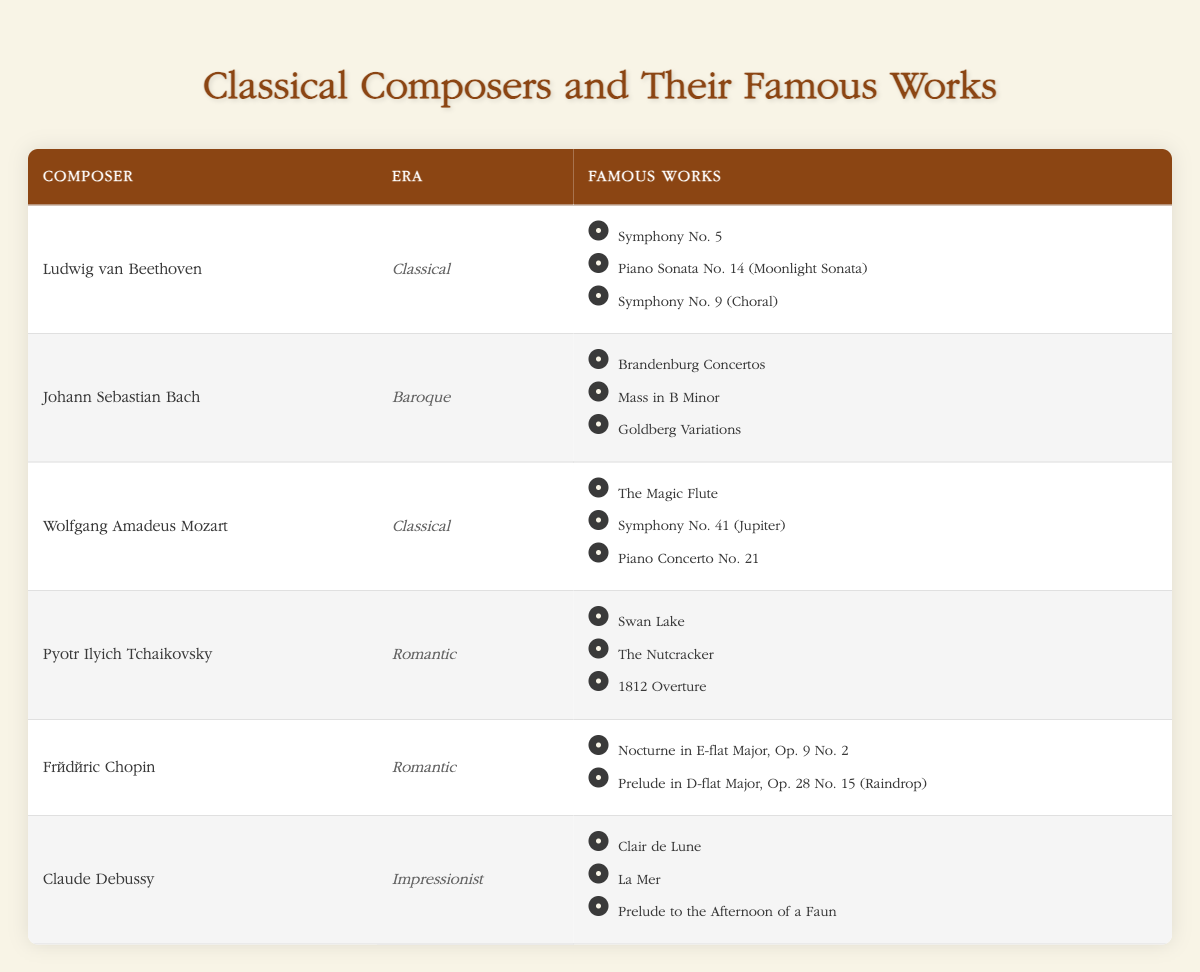What are the famous works of Johann Sebastian Bach? The table shows that Johann Sebastian Bach has three famous works listed: Brandenburg Concertos, Mass in B Minor, and Goldberg Variations.
Answer: Brandenburg Concertos, Mass in B Minor, Goldberg Variations Which composer is associated with the Romantic era and has a work called "Swan Lake"? Looking at the table, Pyotr Ilyich Tchaikovsky is the composer listed in the Romantic era, and one of his famous works is "Swan Lake."
Answer: Pyotr Ilyich Tchaikovsky How many famous works does Frédéric Chopin have listed in the table? The table indicates that Frédéric Chopin has two famous works listed: Nocturne in E-flat Major, Op. 9 No. 2 and Prelude in D-flat Major, Op. 28 No. 15 (Raindrop).
Answer: 2 Is “Clair de Lune” a work by a composer from the Baroque era? The table shows that "Clair de Lune" is a famous work of Claude Debussy, who is associated with the Impressionist era, not the Baroque era. Therefore, the answer is no.
Answer: No Which era has more composers listed: Classical or Romantic? The table lists three composers from the Classical era (Ludwig van Beethoven, Wolfgang Amadeus Mozart) and two composers from the Romantic era (Pyotr Ilyich Tchaikovsky, Frédéric Chopin). Since the Classical era has more composers, the answer is Classical.
Answer: Classical 